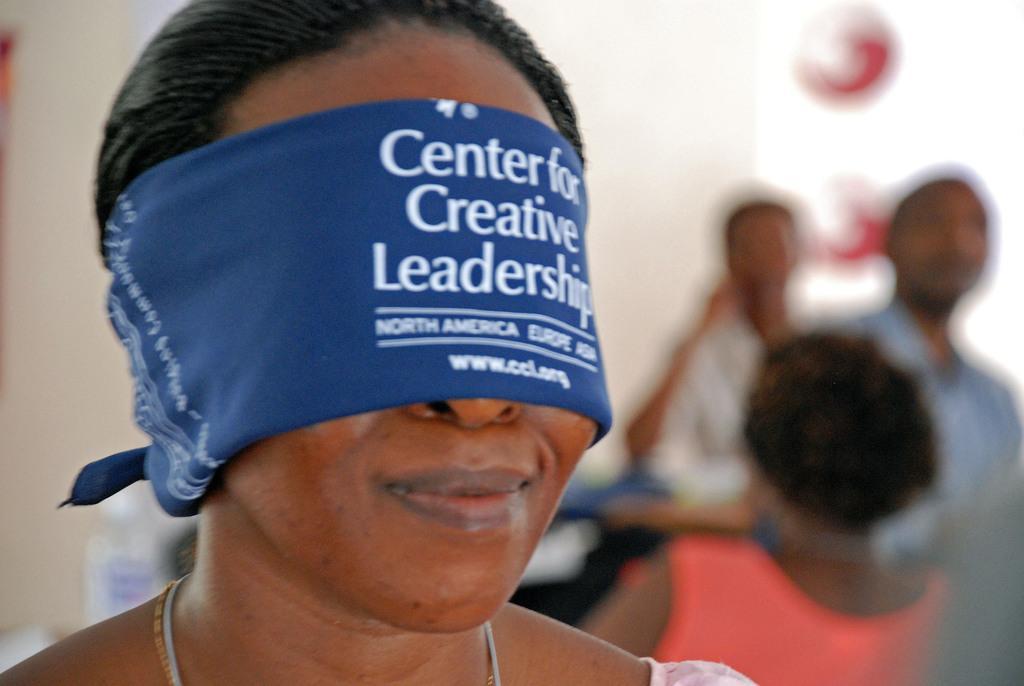Can you describe this image briefly? In this image we can see a woman wearing a blue blindfold. In the background there are people. 